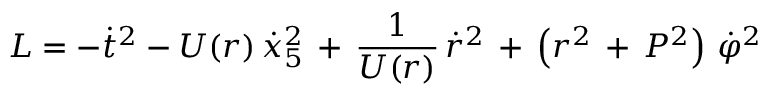Convert formula to latex. <formula><loc_0><loc_0><loc_500><loc_500>L = - { \dot { t } } ^ { 2 } - U ( r ) \, { \dot { x } _ { 5 } } ^ { 2 } \, + \, \frac { 1 } { U ( r ) } \, { \dot { r } } ^ { 2 } \, + \, \left ( r ^ { 2 } \, + \, P ^ { 2 } \right ) \, { \dot { \varphi } } ^ { 2 }</formula> 